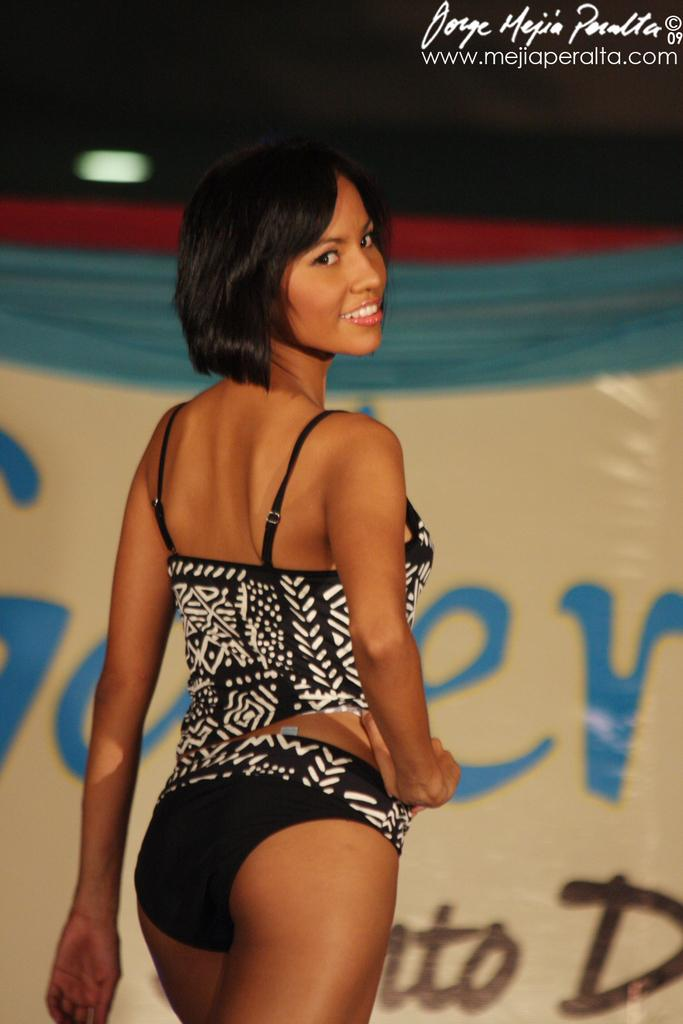Who is present in the image? There is a woman in the image. What is the woman's facial expression? The woman is smiling. What can be seen in the background of the image? There is a banner in the background of the image. What is visible in the image that provides illumination? There is light visible in the image. Where is the text located in the image? The text is in the top right corner of the image. How many pizzas are being served on the table in the image? There is no table or pizzas present in the image. What type of waste is being disposed of in the image? There is no waste present in the image. 